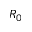<formula> <loc_0><loc_0><loc_500><loc_500>R _ { 0 }</formula> 